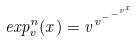<formula> <loc_0><loc_0><loc_500><loc_500>e x p _ { v } ^ { n } ( x ) = v ^ { v ^ { - ^ { - ^ { v ^ { x } } } } }</formula> 